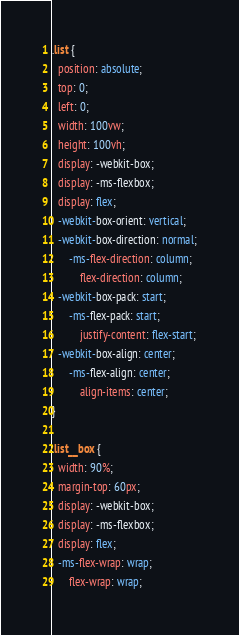Convert code to text. <code><loc_0><loc_0><loc_500><loc_500><_CSS_>.list {
  position: absolute;
  top: 0;
  left: 0;
  width: 100vw;
  height: 100vh;
  display: -webkit-box;
  display: -ms-flexbox;
  display: flex;
  -webkit-box-orient: vertical;
  -webkit-box-direction: normal;
      -ms-flex-direction: column;
          flex-direction: column;
  -webkit-box-pack: start;
      -ms-flex-pack: start;
          justify-content: flex-start;
  -webkit-box-align: center;
      -ms-flex-align: center;
          align-items: center;
}

.list__box {
  width: 90%;
  margin-top: 60px;
  display: -webkit-box;
  display: -ms-flexbox;
  display: flex;
  -ms-flex-wrap: wrap;
      flex-wrap: wrap;</code> 